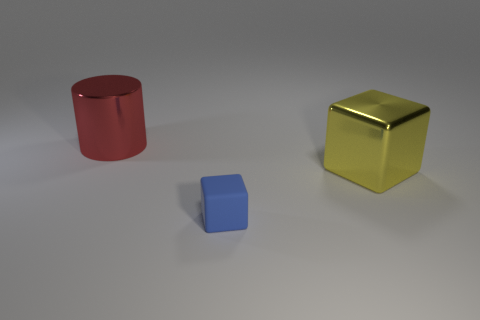There is a metallic object in front of the large thing that is behind the yellow metal cube; what size is it? The object in front of the large item behind the yellow metal cube appears to be a medium-sized blue cube. Its dimensions seem smaller than the yellow cube but larger than being characterized as 'small'. 